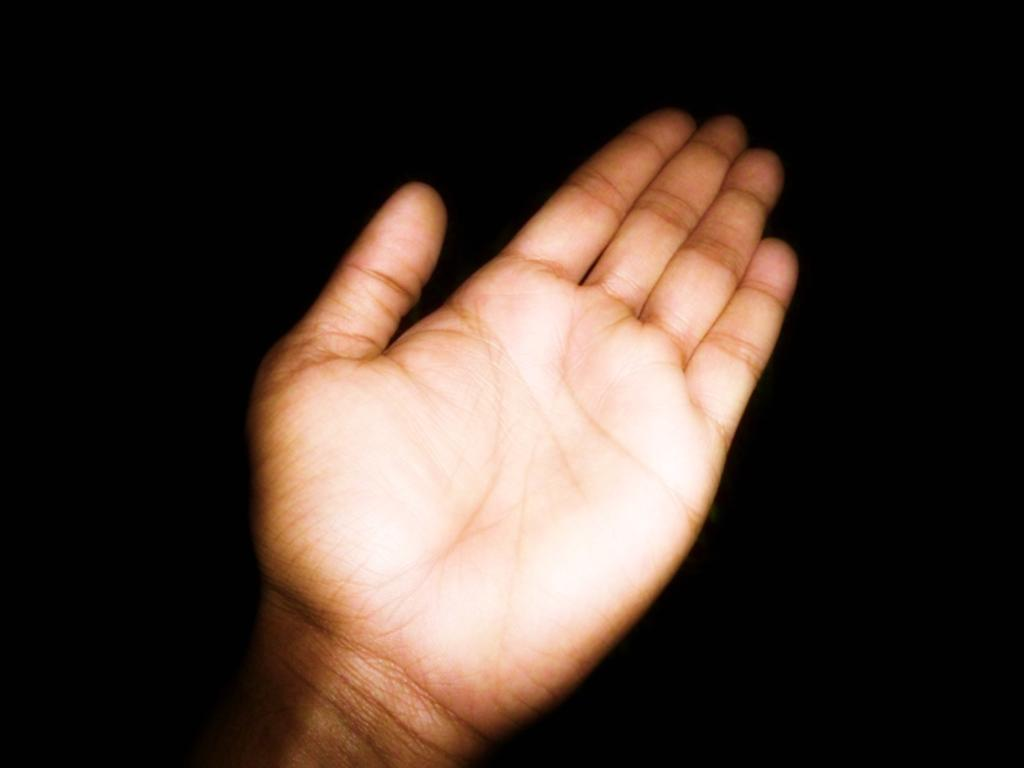What can be seen in the image? There is a hand of a person in the image. What is the color of the background in the image? The background of the image is black. What type of bell is hanging from the dress in the image? There is no bell or dress present in the image; only a hand is visible. How many geese are flying in the image? There are no geese present in the image. 